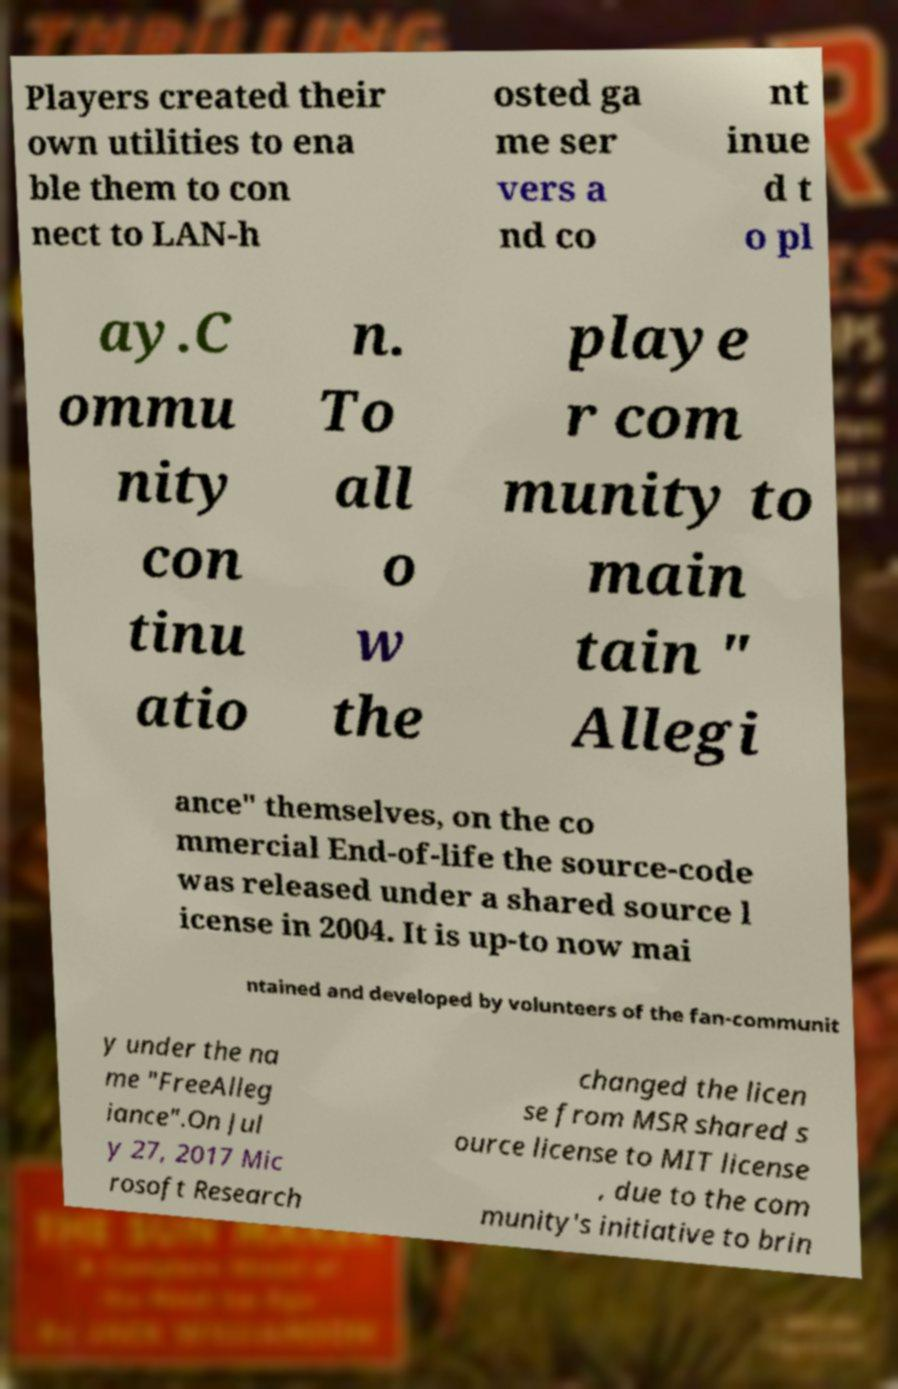Could you assist in decoding the text presented in this image and type it out clearly? Players created their own utilities to ena ble them to con nect to LAN-h osted ga me ser vers a nd co nt inue d t o pl ay.C ommu nity con tinu atio n. To all o w the playe r com munity to main tain " Allegi ance" themselves, on the co mmercial End-of-life the source-code was released under a shared source l icense in 2004. It is up-to now mai ntained and developed by volunteers of the fan-communit y under the na me "FreeAlleg iance".On Jul y 27, 2017 Mic rosoft Research changed the licen se from MSR shared s ource license to MIT license , due to the com munity's initiative to brin 